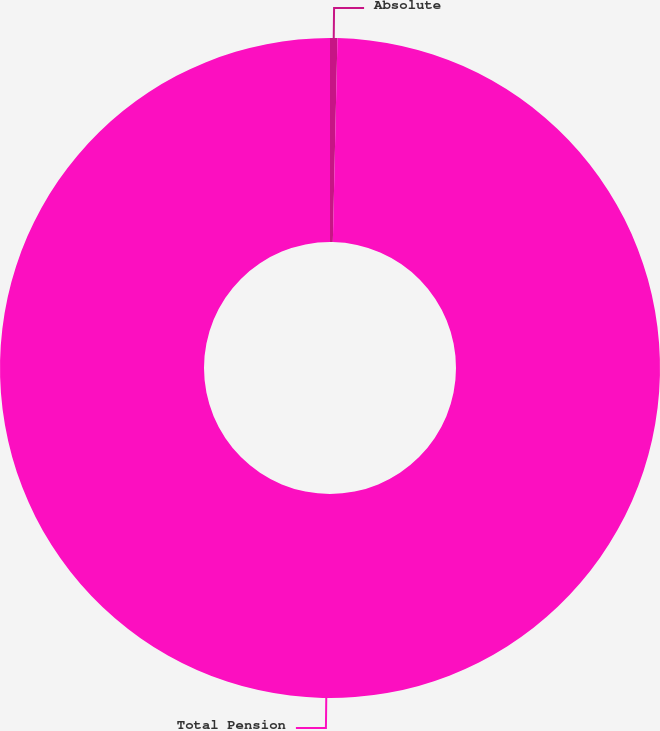Convert chart to OTSL. <chart><loc_0><loc_0><loc_500><loc_500><pie_chart><fcel>Absolute<fcel>Total Pension<nl><fcel>0.36%<fcel>99.64%<nl></chart> 